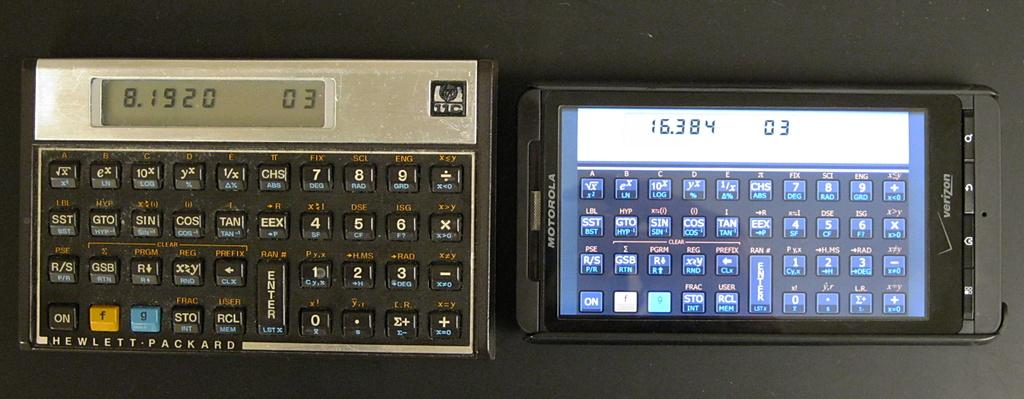<image>
Relay a brief, clear account of the picture shown. A calculator is next to a Verizon phone that shows a scientific calculator on the screen. 